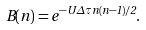Convert formula to latex. <formula><loc_0><loc_0><loc_500><loc_500>B ( n ) = e ^ { - U \Delta \tau n ( n - 1 ) / 2 } .</formula> 